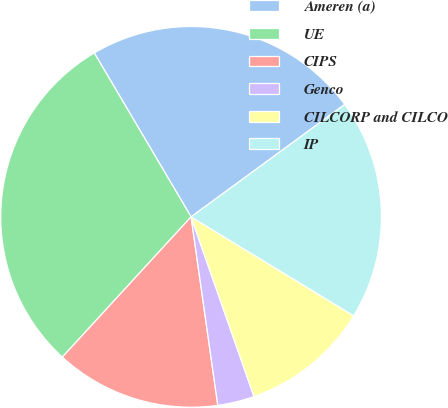<chart> <loc_0><loc_0><loc_500><loc_500><pie_chart><fcel>Ameren (a)<fcel>UE<fcel>CIPS<fcel>Genco<fcel>CILCORP and CILCO<fcel>IP<nl><fcel>23.44%<fcel>29.69%<fcel>14.06%<fcel>3.12%<fcel>10.94%<fcel>18.75%<nl></chart> 